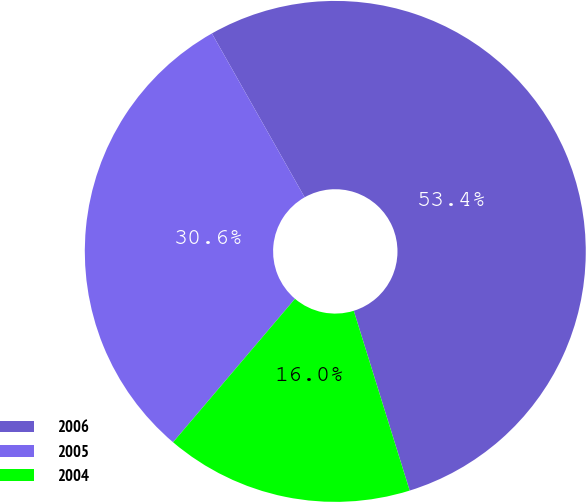Convert chart to OTSL. <chart><loc_0><loc_0><loc_500><loc_500><pie_chart><fcel>2006<fcel>2005<fcel>2004<nl><fcel>53.4%<fcel>30.59%<fcel>16.01%<nl></chart> 